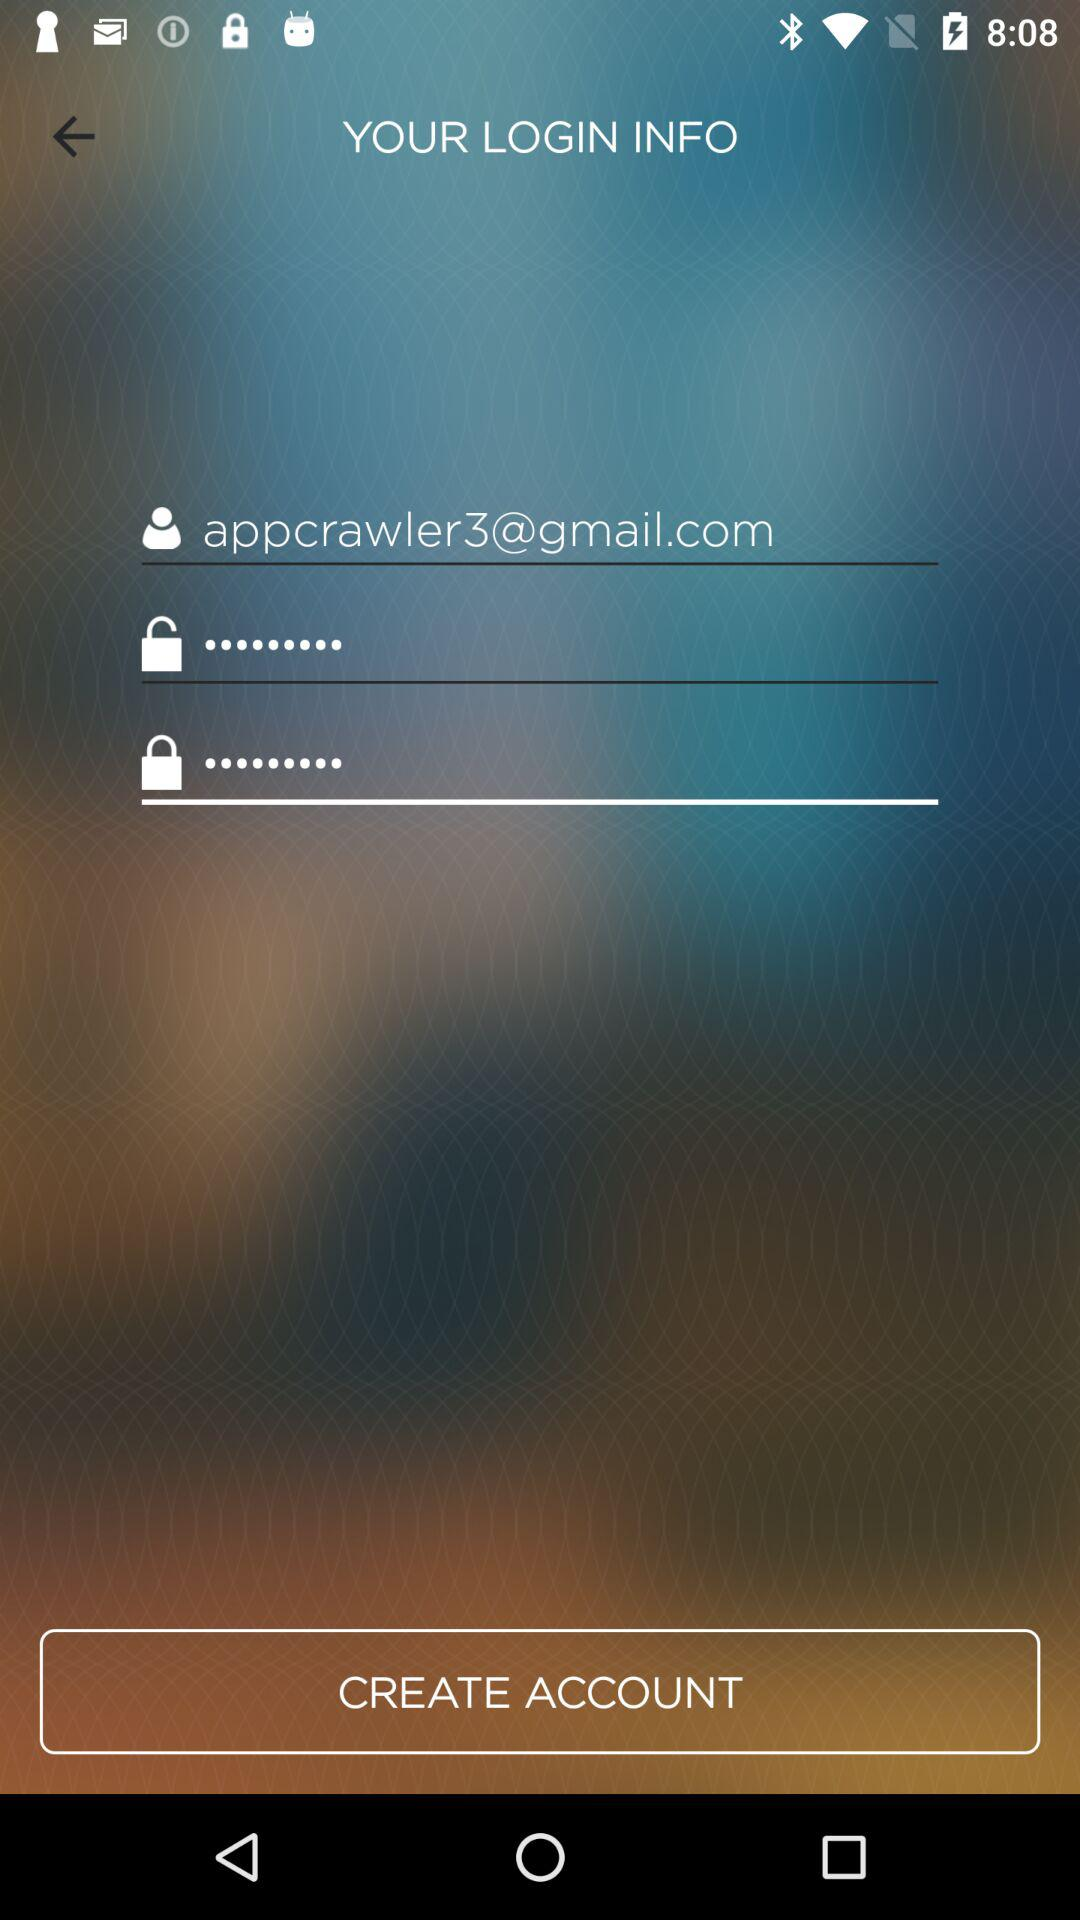What is the entered password?
When the provided information is insufficient, respond with <no answer>. <no answer> 